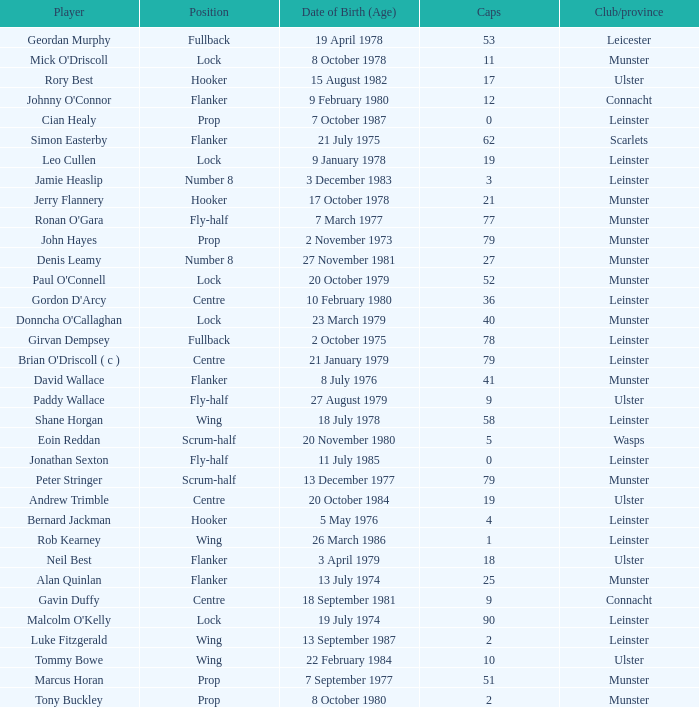What Club/province have caps less than 2 and Jonathan Sexton as player? Leinster. 